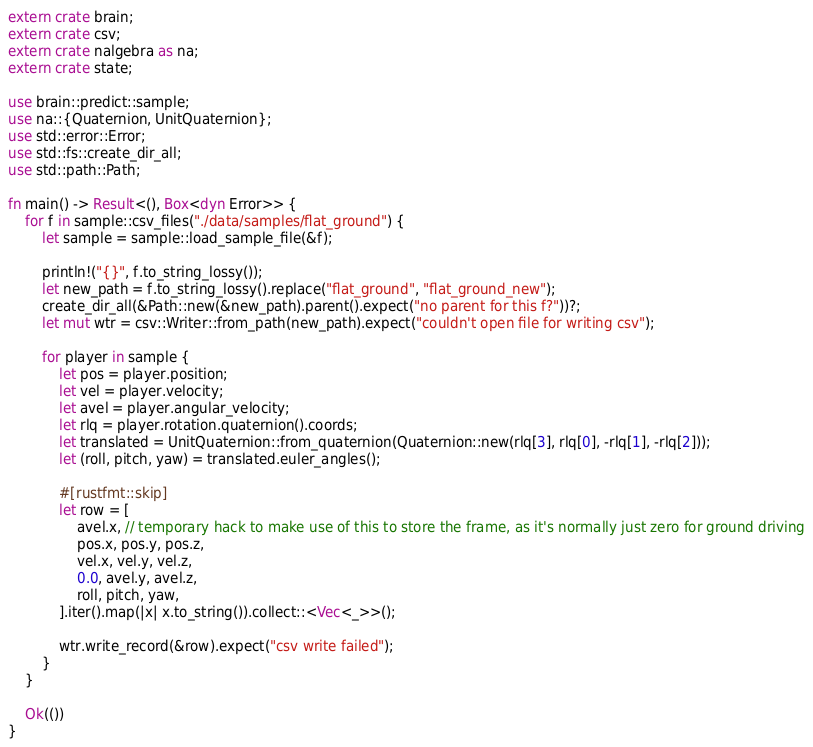<code> <loc_0><loc_0><loc_500><loc_500><_Rust_>extern crate brain;
extern crate csv;
extern crate nalgebra as na;
extern crate state;

use brain::predict::sample;
use na::{Quaternion, UnitQuaternion};
use std::error::Error;
use std::fs::create_dir_all;
use std::path::Path;

fn main() -> Result<(), Box<dyn Error>> {
    for f in sample::csv_files("./data/samples/flat_ground") {
        let sample = sample::load_sample_file(&f);

        println!("{}", f.to_string_lossy());
        let new_path = f.to_string_lossy().replace("flat_ground", "flat_ground_new");
        create_dir_all(&Path::new(&new_path).parent().expect("no parent for this f?"))?;
        let mut wtr = csv::Writer::from_path(new_path).expect("couldn't open file for writing csv");

        for player in sample {
            let pos = player.position;
            let vel = player.velocity;
            let avel = player.angular_velocity;
            let rlq = player.rotation.quaternion().coords;
            let translated = UnitQuaternion::from_quaternion(Quaternion::new(rlq[3], rlq[0], -rlq[1], -rlq[2]));
            let (roll, pitch, yaw) = translated.euler_angles();

            #[rustfmt::skip]
            let row = [
                avel.x, // temporary hack to make use of this to store the frame, as it's normally just zero for ground driving
                pos.x, pos.y, pos.z,
                vel.x, vel.y, vel.z,
                0.0, avel.y, avel.z,
                roll, pitch, yaw,
            ].iter().map(|x| x.to_string()).collect::<Vec<_>>();

            wtr.write_record(&row).expect("csv write failed");
        }
    }

    Ok(())
}
</code> 